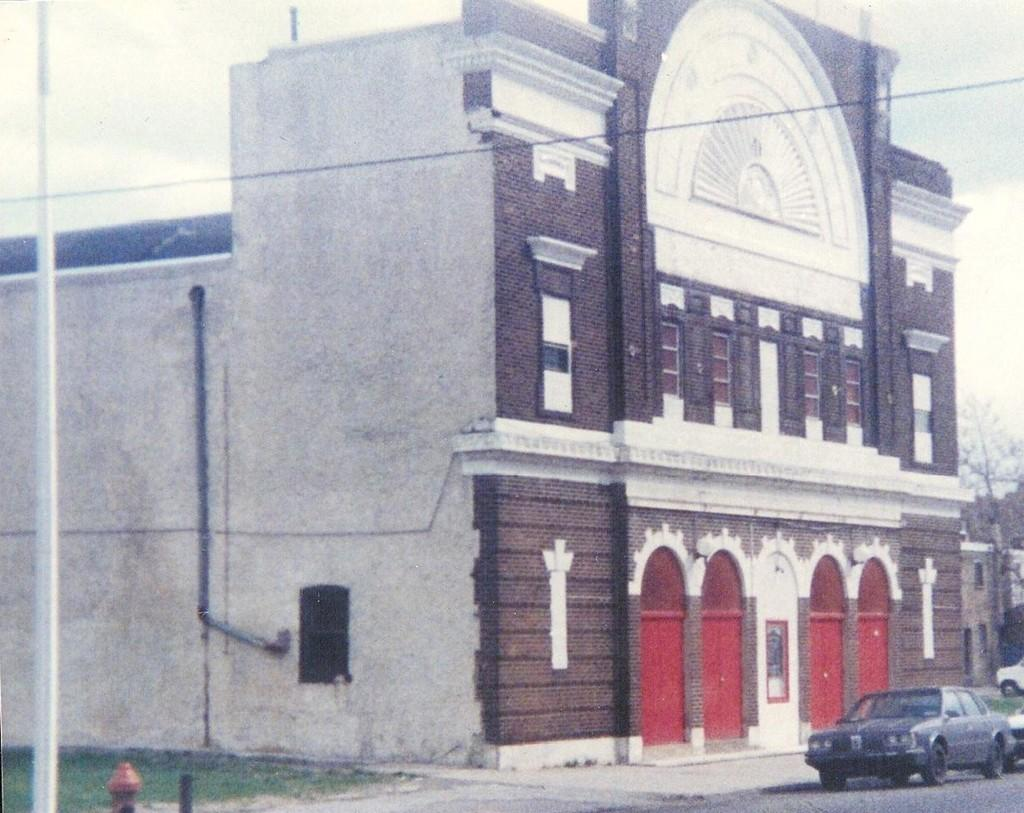What can be seen on the road in the image? There are vehicles on the road in the image. What type of vegetation is visible in the image? There is green grass visible in the image. What else can be seen in the image besides the road and vehicles? There are trees and a building in the image. What letter is the minister holding in the image? There is no minister or letter present in the image. 